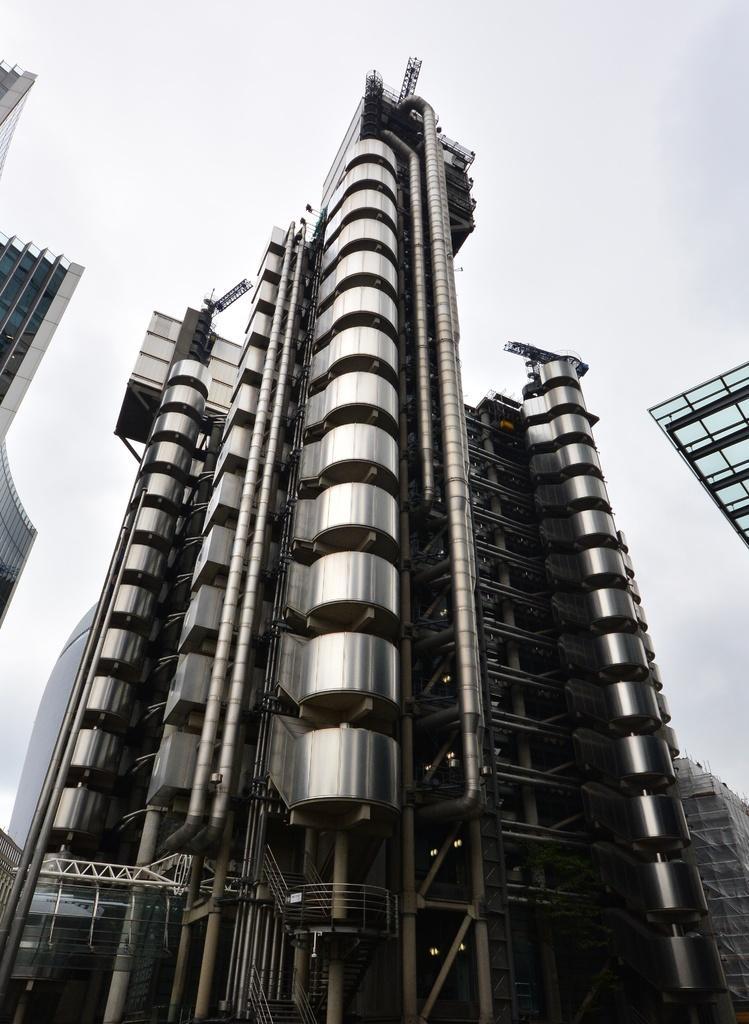How would you summarize this image in a sentence or two? In this image we can see buildings. At the top of the image there is sky. 